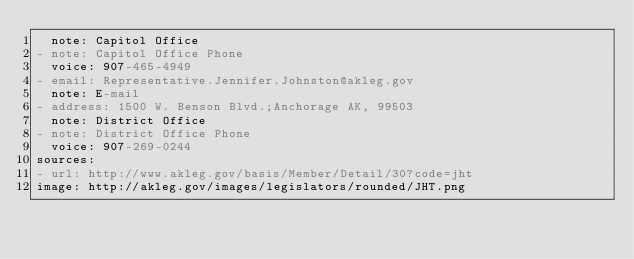Convert code to text. <code><loc_0><loc_0><loc_500><loc_500><_YAML_>  note: Capitol Office
- note: Capitol Office Phone
  voice: 907-465-4949
- email: Representative.Jennifer.Johnston@akleg.gov
  note: E-mail
- address: 1500 W. Benson Blvd.;Anchorage AK, 99503
  note: District Office
- note: District Office Phone
  voice: 907-269-0244
sources:
- url: http://www.akleg.gov/basis/Member/Detail/30?code=jht
image: http://akleg.gov/images/legislators/rounded/JHT.png
</code> 